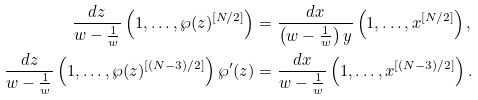Convert formula to latex. <formula><loc_0><loc_0><loc_500><loc_500>\frac { d z } { w - \frac { 1 } { w } } \left ( 1 , \dots , \wp ( z ) ^ { [ N / 2 ] } \right ) & = \frac { d x } { \left ( w - \frac { 1 } { w } \right ) y } \left ( 1 , \dots , x ^ { [ N / 2 ] } \right ) , \\ \frac { d z } { w - \frac { 1 } { w } } \left ( 1 , \dots , \wp ( z ) ^ { [ ( N - 3 ) / 2 ] } \right ) \wp ^ { \prime } ( z ) & = \frac { d x } { w - \frac { 1 } { w } } \left ( 1 , \dots , x ^ { [ ( N - 3 ) / 2 ] } \right ) .</formula> 